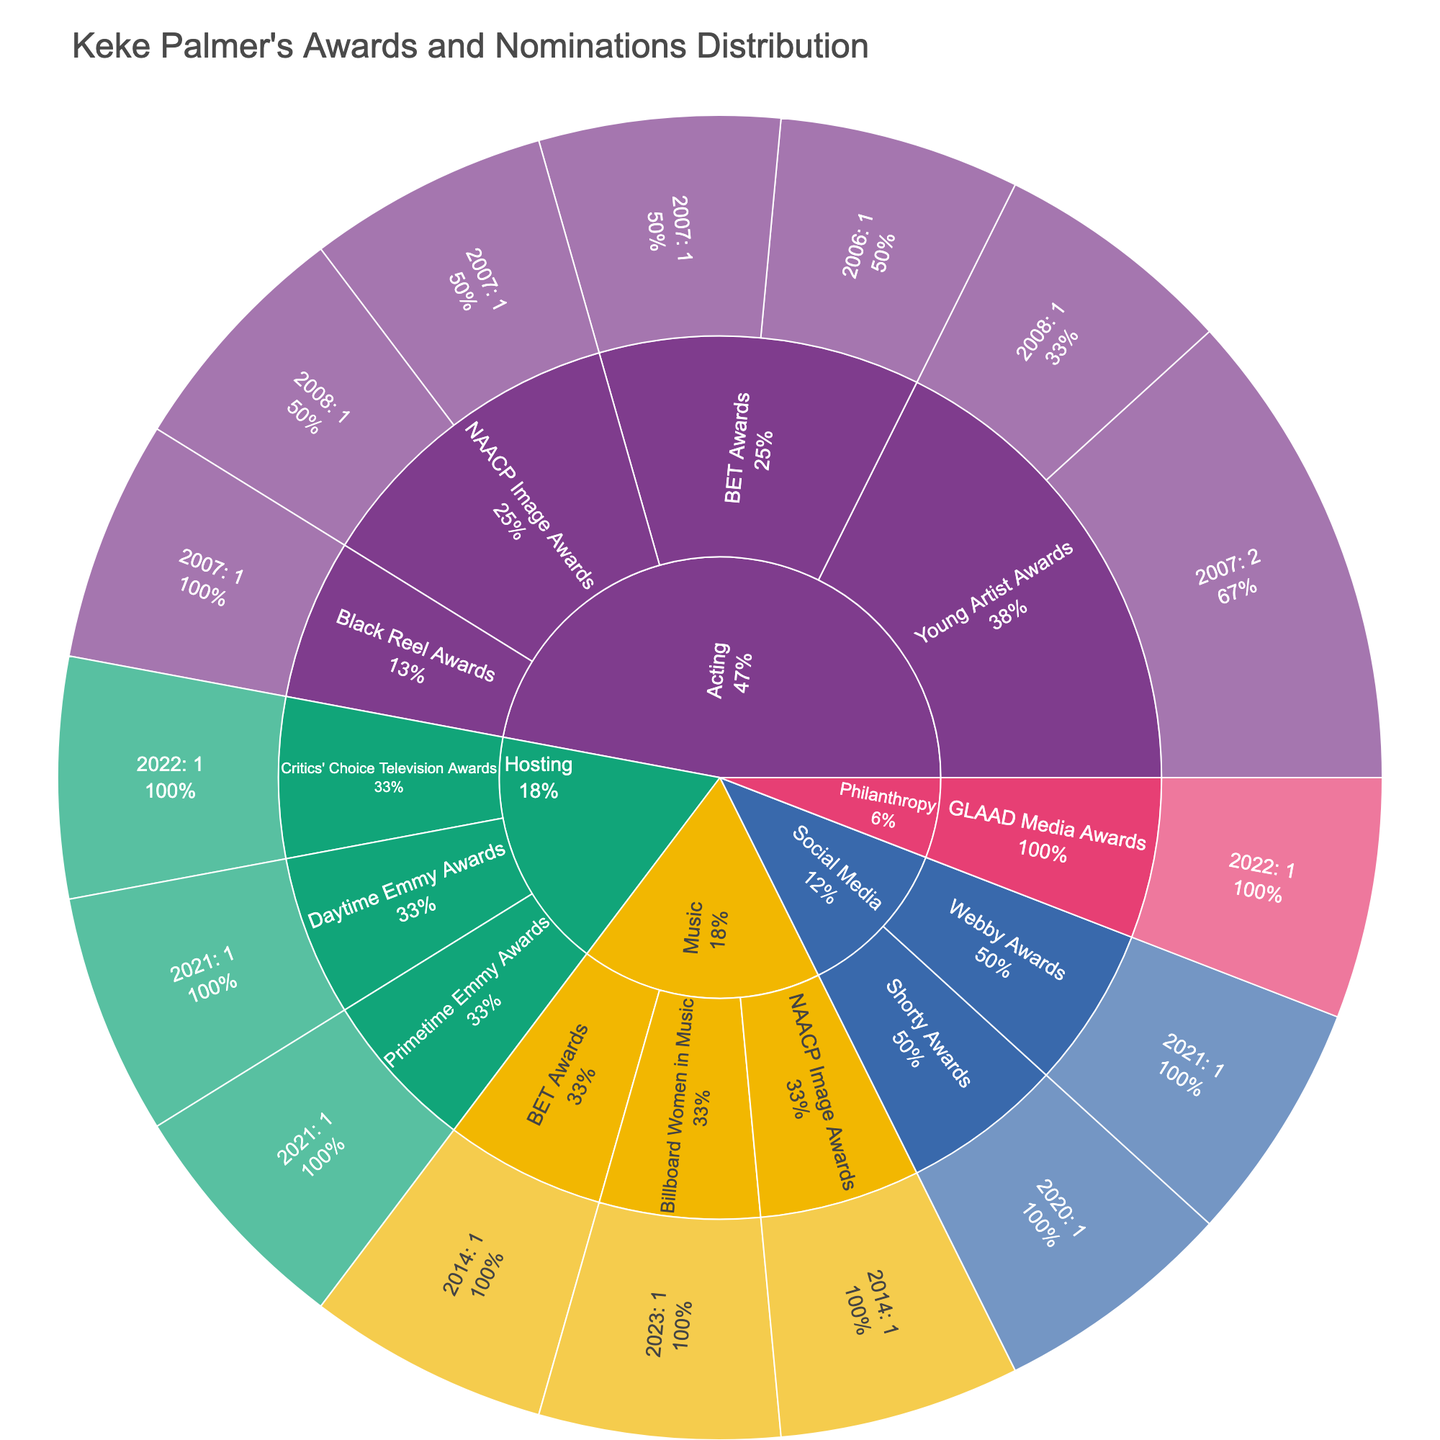What is the title of the sunburst plot? The title is usually located at the top of the plot and provides a brief description of what the plot represents. In this case, the title given in the code is "Keke Palmer's Awards and Nominations Distribution".
Answer: Keke Palmer's Awards and Nominations Distribution How many overall categories are depicted in the sunburst plot? The categories form the outermost layer of the sunburst plot. By counting these segments, we can determine the number of overall categories. The categories are Acting, Music, Hosting, Social Media, and Philanthropy.
Answer: 5 Which subcategory has the highest number of awards/nominations in the Acting category? We look at the subcategories within the Acting segment and compare their values. The "Young Artist Awards" subcategory has a total of 3 awards/nominations.
Answer: Young Artist Awards In which year did Keke Palmer receive an award/nomination for GLAAD Media Awards? The GLAAD Media Awards is a subcategory, and the specific year is a sublabel within this subcategory. By finding GLAAD Media Awards, we can identify the year associated with it.
Answer: 2022 How many awards/nominations did Keke Palmer receive in 2007 across all categories? Summing up all the values for the different subcategories in the year 2007: 1 (BET Awards) + 1 (NAACP Image Awards) + 1 (Black Reel Awards) + 2 (Young Artist Awards).
Answer: 5 Compare the number of awards/nominations in the Music and Hosting categories. Which category has more, and by how much? Sum the values for each subcategory in both categories: Music (1+1+1) = 3, Hosting (1+1+1) = 3. Both categories have the same number of awards/nominations.
Answer: Both categories have the same number What percentage of awards/nominations belong to the year 2021 in the Hosting category? In the Hosting category, add the values for all 2021 subcategories, then calculate the percentage out of the total Hosting category values: (1+1) / 3 = (2/3) * 100%.
Answer: 66.67% How many total awards/nominations does the sunburst plot represent? Summing all values provided across every category and subcategory: 1+1+1+1+1+2+1+1+1+1+1+1+1+1+1+1 = 16.
Answer: 16 Is there any year in which Keke Palmer received awards/nominations in more than one subcategory within the same category? Looking through each year, we find that in 2007 within the Acting category, Keke Palmer received awards/nominations in BET Awards, NAACP Image Awards, Black Reel Awards, and Young Artist Awards.
Answer: Yes, in 2007, in the Acting category Which category features the latest (most recent) award/nomination in the plot? By identifying the latest year across all categories, we find that the Billboard Women in Music in the Music category is from 2023.
Answer: Music 